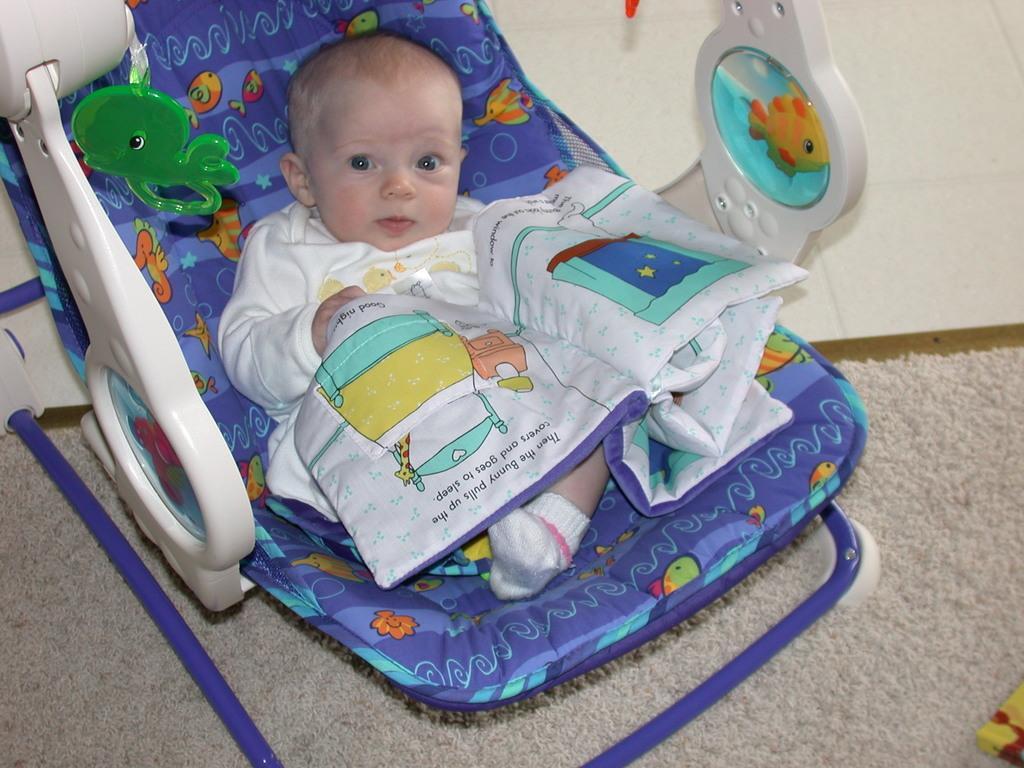Please provide a concise description of this image. In the middle of the image we can see a baby in the cradle and we can see a mat. 